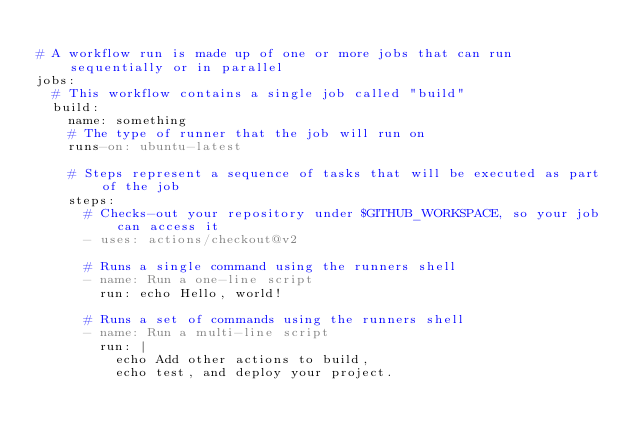<code> <loc_0><loc_0><loc_500><loc_500><_YAML_>
# A workflow run is made up of one or more jobs that can run sequentially or in parallel
jobs:
  # This workflow contains a single job called "build"
  build:
    name: something
    # The type of runner that the job will run on
    runs-on: ubuntu-latest

    # Steps represent a sequence of tasks that will be executed as part of the job
    steps:
      # Checks-out your repository under $GITHUB_WORKSPACE, so your job can access it
      - uses: actions/checkout@v2

      # Runs a single command using the runners shell
      - name: Run a one-line script
        run: echo Hello, world!

      # Runs a set of commands using the runners shell
      - name: Run a multi-line script
        run: |
          echo Add other actions to build,
          echo test, and deploy your project.</code> 